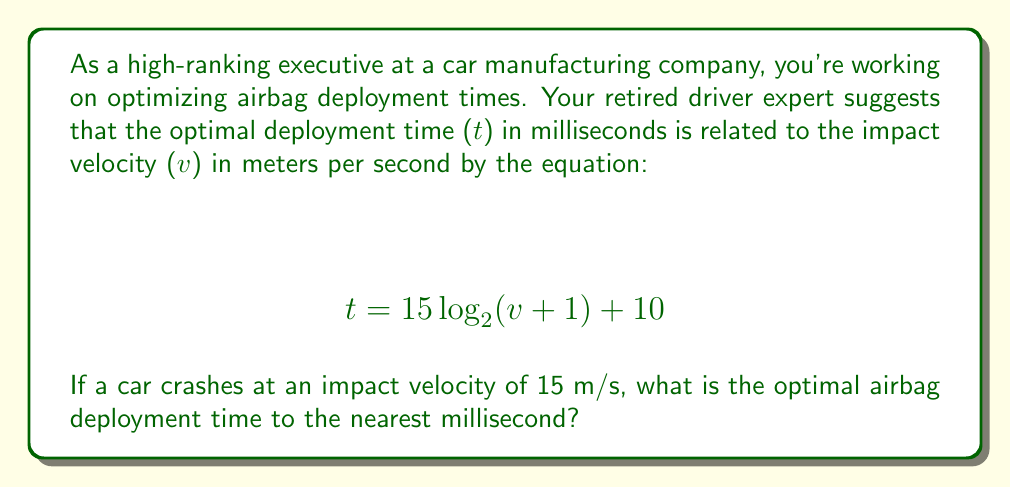Show me your answer to this math problem. To solve this problem, we need to use the given logarithmic equation and substitute the known impact velocity. Let's break it down step-by-step:

1. We're given the equation: $$ t = 15 \log_2(v + 1) + 10 $$

2. We know the impact velocity, v = 15 m/s. Let's substitute this into the equation:
   $$ t = 15 \log_2(15 + 1) + 10 $$
   $$ t = 15 \log_2(16) + 10 $$

3. Now, we need to evaluate $\log_2(16)$:
   $2^4 = 16$, so $\log_2(16) = 4$

4. Substituting this back into our equation:
   $$ t = 15 \cdot 4 + 10 $$
   $$ t = 60 + 10 $$
   $$ t = 70 $$

5. The question asks for the answer to the nearest millisecond, but our result is already a whole number, so no rounding is necessary.

Therefore, the optimal airbag deployment time for an impact velocity of 15 m/s is 70 milliseconds.
Answer: 70 milliseconds 